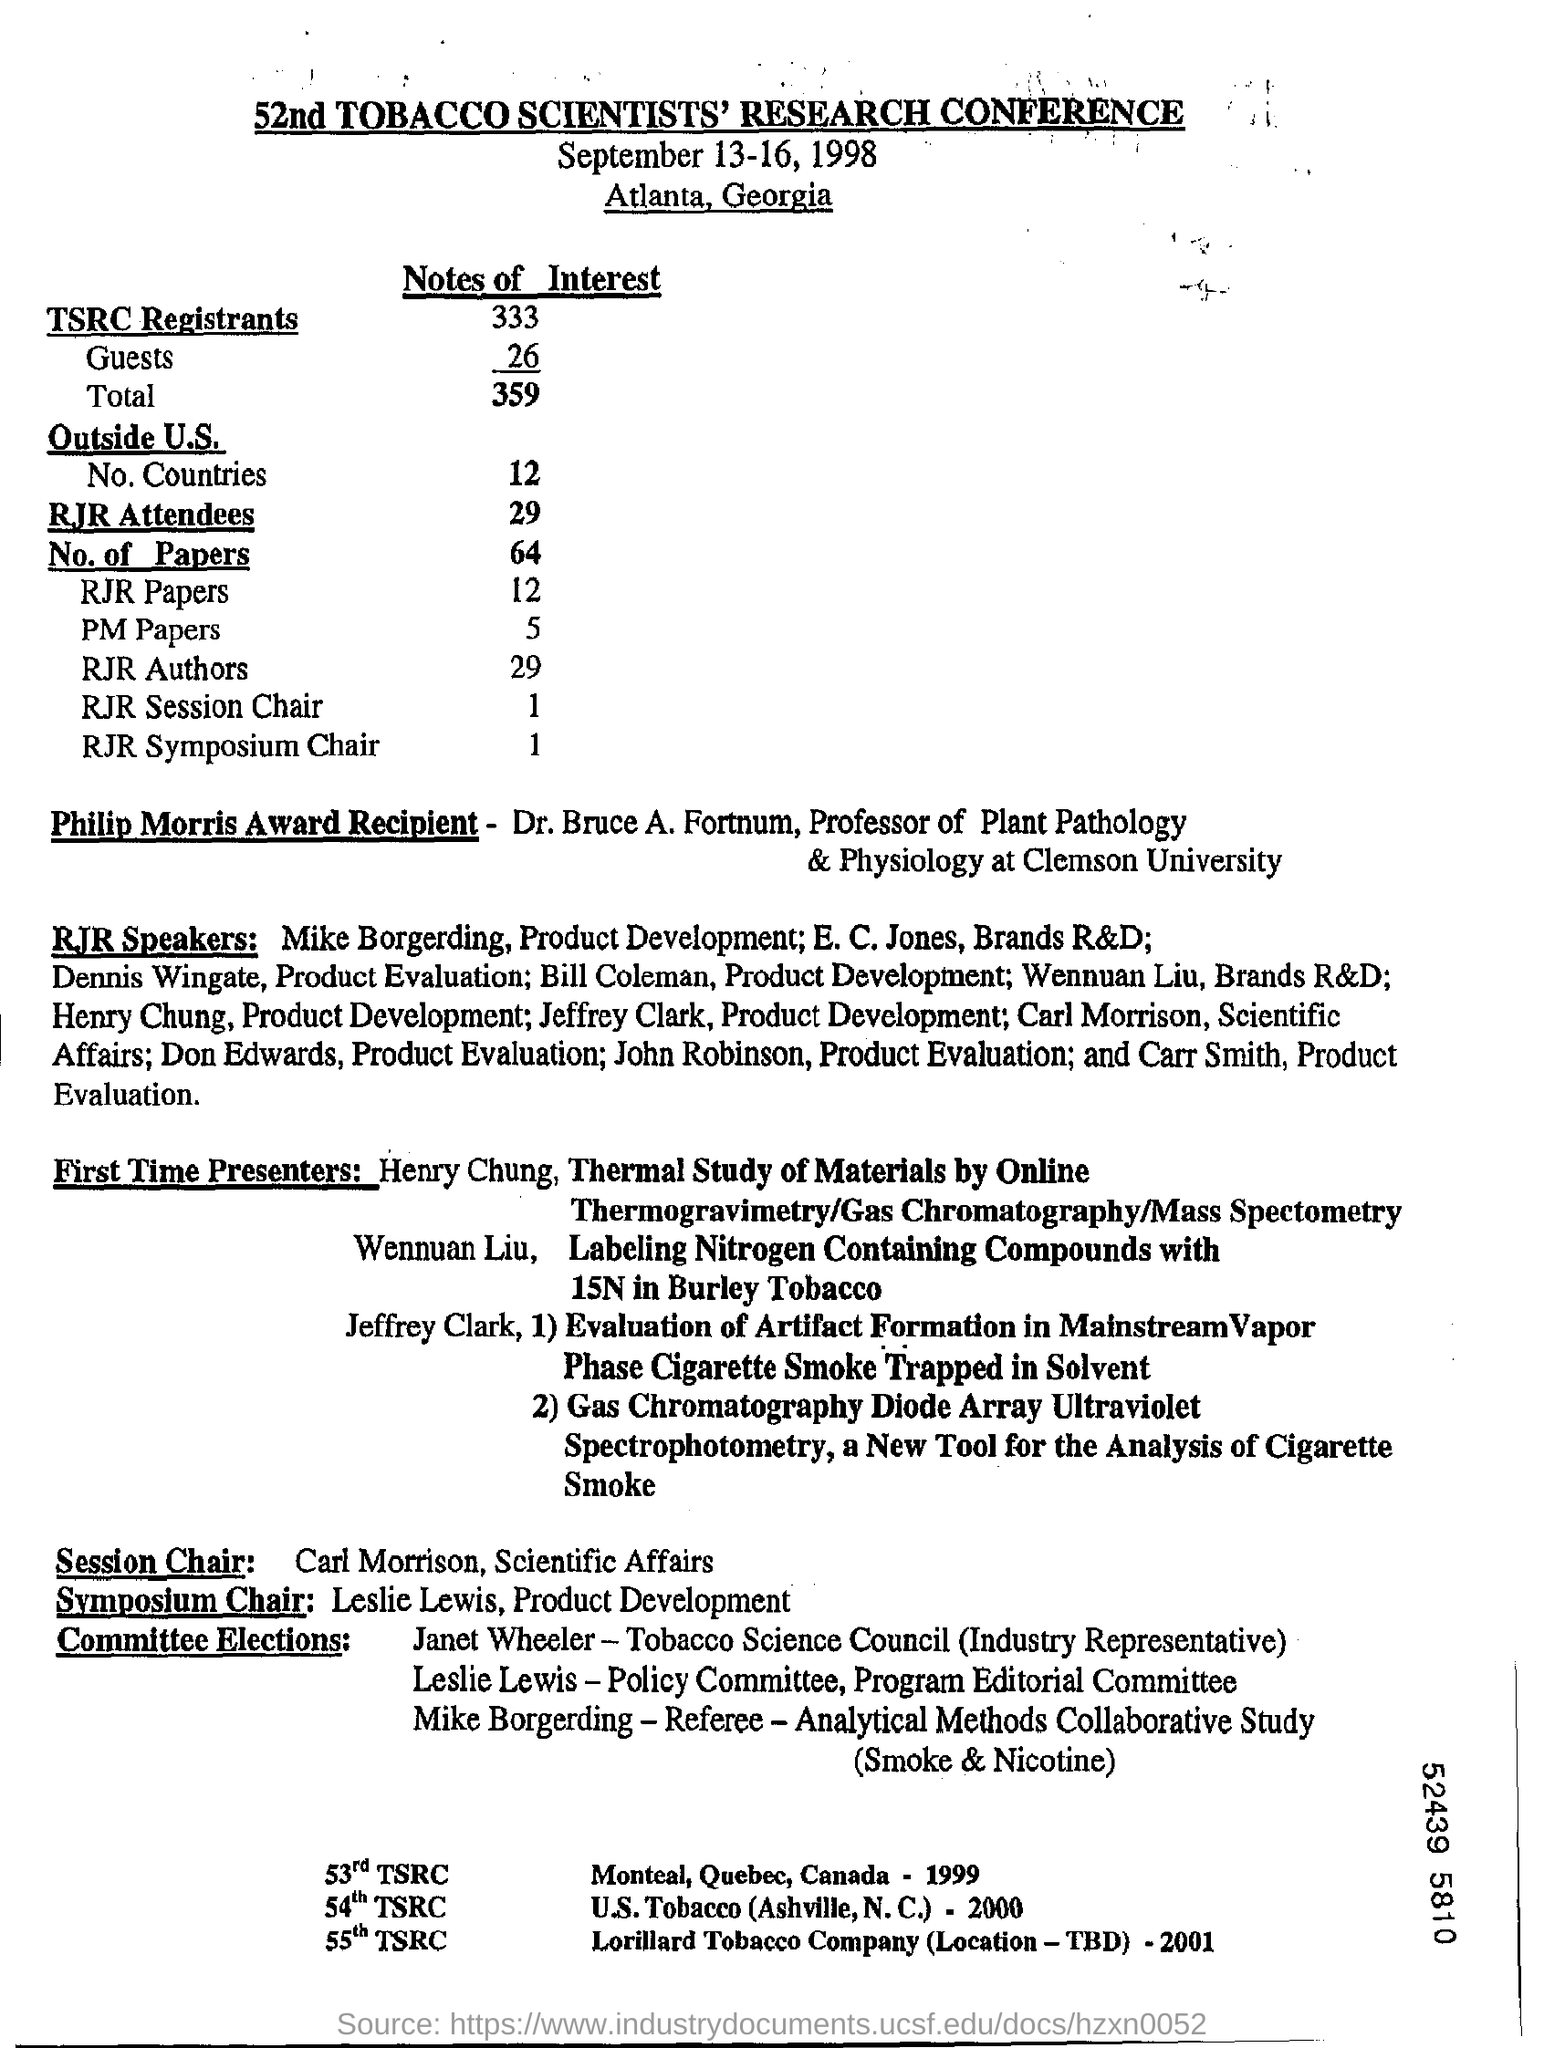Outline some significant characteristics in this image. The date mentioned at the top of the document is September 13-16, 1998. The 52nd Tobacco Scientists' Research Conference is the title of the document. 